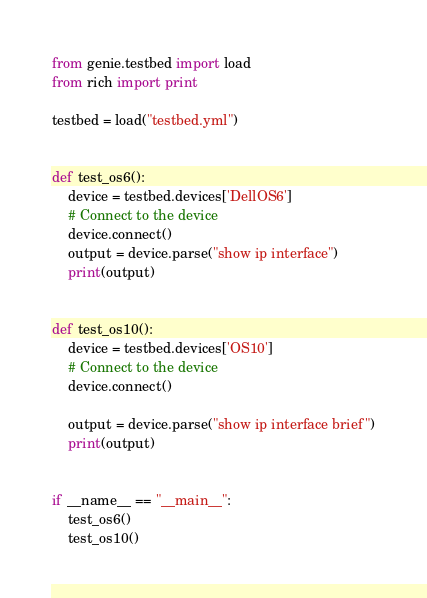<code> <loc_0><loc_0><loc_500><loc_500><_Python_>from genie.testbed import load
from rich import print

testbed = load("testbed.yml")


def test_os6():
    device = testbed.devices['DellOS6']
    # Connect to the device
    device.connect()
    output = device.parse("show ip interface")
    print(output)


def test_os10():
    device = testbed.devices['OS10']
    # Connect to the device
    device.connect()

    output = device.parse("show ip interface brief")
    print(output)


if __name__ == "__main__":
    test_os6()
    test_os10()
</code> 